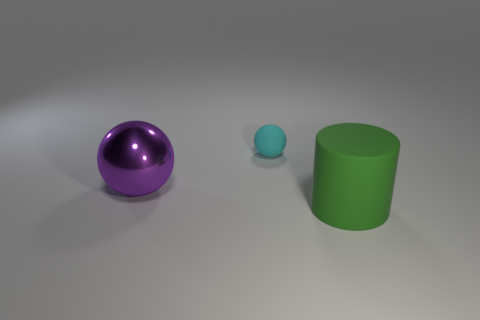Add 1 tiny yellow shiny balls. How many objects exist? 4 Subtract all cylinders. How many objects are left? 2 Add 1 tiny cyan matte balls. How many tiny cyan matte balls are left? 2 Add 2 green cylinders. How many green cylinders exist? 3 Subtract 0 brown cylinders. How many objects are left? 3 Subtract all red blocks. Subtract all rubber things. How many objects are left? 1 